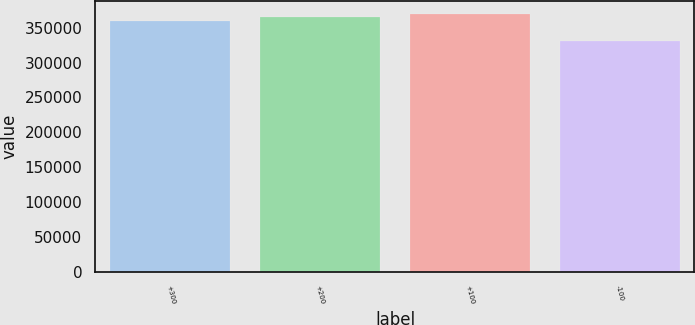<chart> <loc_0><loc_0><loc_500><loc_500><bar_chart><fcel>+300<fcel>+200<fcel>+100<fcel>-100<nl><fcel>359150<fcel>365585<fcel>369258<fcel>331083<nl></chart> 